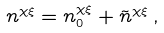Convert formula to latex. <formula><loc_0><loc_0><loc_500><loc_500>n ^ { \chi \xi } = n _ { 0 } ^ { \chi \xi } + \tilde { n } ^ { \chi \xi } \, ,</formula> 